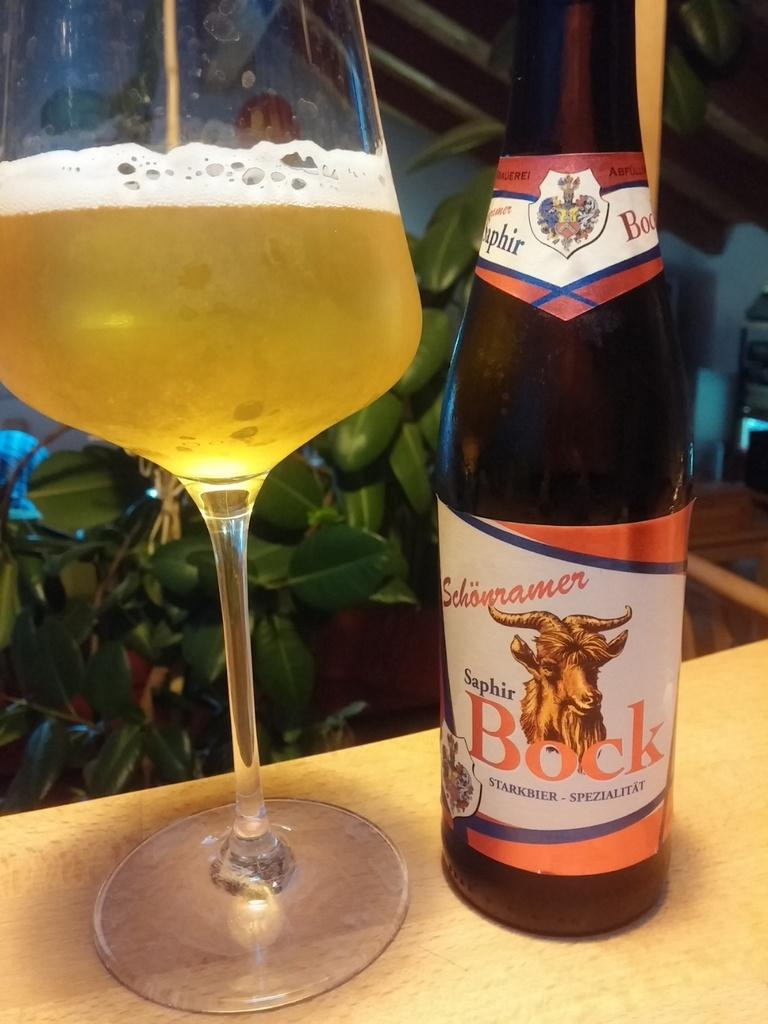<image>
Describe the image concisely. A bottle of Bock booze next to a glass of liquid. 